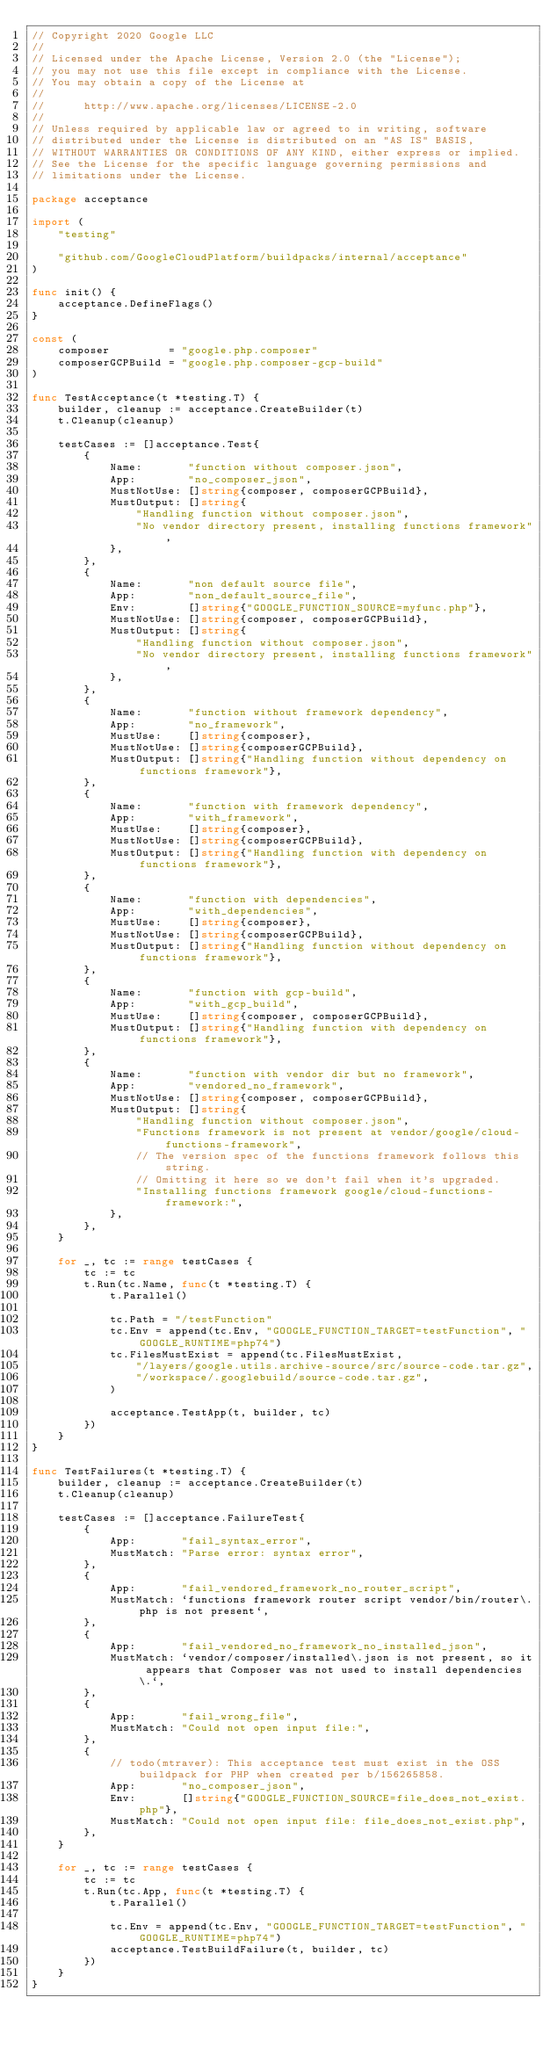Convert code to text. <code><loc_0><loc_0><loc_500><loc_500><_Go_>// Copyright 2020 Google LLC
//
// Licensed under the Apache License, Version 2.0 (the "License");
// you may not use this file except in compliance with the License.
// You may obtain a copy of the License at
//
//      http://www.apache.org/licenses/LICENSE-2.0
//
// Unless required by applicable law or agreed to in writing, software
// distributed under the License is distributed on an "AS IS" BASIS,
// WITHOUT WARRANTIES OR CONDITIONS OF ANY KIND, either express or implied.
// See the License for the specific language governing permissions and
// limitations under the License.

package acceptance

import (
	"testing"

	"github.com/GoogleCloudPlatform/buildpacks/internal/acceptance"
)

func init() {
	acceptance.DefineFlags()
}

const (
	composer         = "google.php.composer"
	composerGCPBuild = "google.php.composer-gcp-build"
)

func TestAcceptance(t *testing.T) {
	builder, cleanup := acceptance.CreateBuilder(t)
	t.Cleanup(cleanup)

	testCases := []acceptance.Test{
		{
			Name:       "function without composer.json",
			App:        "no_composer_json",
			MustNotUse: []string{composer, composerGCPBuild},
			MustOutput: []string{
				"Handling function without composer.json",
				"No vendor directory present, installing functions framework",
			},
		},
		{
			Name:       "non default source file",
			App:        "non_default_source_file",
			Env:        []string{"GOOGLE_FUNCTION_SOURCE=myfunc.php"},
			MustNotUse: []string{composer, composerGCPBuild},
			MustOutput: []string{
				"Handling function without composer.json",
				"No vendor directory present, installing functions framework",
			},
		},
		{
			Name:       "function without framework dependency",
			App:        "no_framework",
			MustUse:    []string{composer},
			MustNotUse: []string{composerGCPBuild},
			MustOutput: []string{"Handling function without dependency on functions framework"},
		},
		{
			Name:       "function with framework dependency",
			App:        "with_framework",
			MustUse:    []string{composer},
			MustNotUse: []string{composerGCPBuild},
			MustOutput: []string{"Handling function with dependency on functions framework"},
		},
		{
			Name:       "function with dependencies",
			App:        "with_dependencies",
			MustUse:    []string{composer},
			MustNotUse: []string{composerGCPBuild},
			MustOutput: []string{"Handling function without dependency on functions framework"},
		},
		{
			Name:       "function with gcp-build",
			App:        "with_gcp_build",
			MustUse:    []string{composer, composerGCPBuild},
			MustOutput: []string{"Handling function with dependency on functions framework"},
		},
		{
			Name:       "function with vendor dir but no framework",
			App:        "vendored_no_framework",
			MustNotUse: []string{composer, composerGCPBuild},
			MustOutput: []string{
				"Handling function without composer.json",
				"Functions framework is not present at vendor/google/cloud-functions-framework",
				// The version spec of the functions framework follows this string.
				// Omitting it here so we don't fail when it's upgraded.
				"Installing functions framework google/cloud-functions-framework:",
			},
		},
	}

	for _, tc := range testCases {
		tc := tc
		t.Run(tc.Name, func(t *testing.T) {
			t.Parallel()

			tc.Path = "/testFunction"
			tc.Env = append(tc.Env, "GOOGLE_FUNCTION_TARGET=testFunction", "GOOGLE_RUNTIME=php74")
			tc.FilesMustExist = append(tc.FilesMustExist,
				"/layers/google.utils.archive-source/src/source-code.tar.gz",
				"/workspace/.googlebuild/source-code.tar.gz",
			)

			acceptance.TestApp(t, builder, tc)
		})
	}
}

func TestFailures(t *testing.T) {
	builder, cleanup := acceptance.CreateBuilder(t)
	t.Cleanup(cleanup)

	testCases := []acceptance.FailureTest{
		{
			App:       "fail_syntax_error",
			MustMatch: "Parse error: syntax error",
		},
		{
			App:       "fail_vendored_framework_no_router_script",
			MustMatch: `functions framework router script vendor/bin/router\.php is not present`,
		},
		{
			App:       "fail_vendored_no_framework_no_installed_json",
			MustMatch: `vendor/composer/installed\.json is not present, so it appears that Composer was not used to install dependencies\.`,
		},
		{
			App:       "fail_wrong_file",
			MustMatch: "Could not open input file:",
		},
		{
			// todo(mtraver): This acceptance test must exist in the OSS buildpack for PHP when created per b/156265858.
			App:       "no_composer_json",
			Env:       []string{"GOOGLE_FUNCTION_SOURCE=file_does_not_exist.php"},
			MustMatch: "Could not open input file: file_does_not_exist.php",
		},
	}

	for _, tc := range testCases {
		tc := tc
		t.Run(tc.App, func(t *testing.T) {
			t.Parallel()

			tc.Env = append(tc.Env, "GOOGLE_FUNCTION_TARGET=testFunction", "GOOGLE_RUNTIME=php74")
			acceptance.TestBuildFailure(t, builder, tc)
		})
	}
}
</code> 